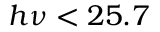<formula> <loc_0><loc_0><loc_500><loc_500>h \nu < 2 5 . 7</formula> 